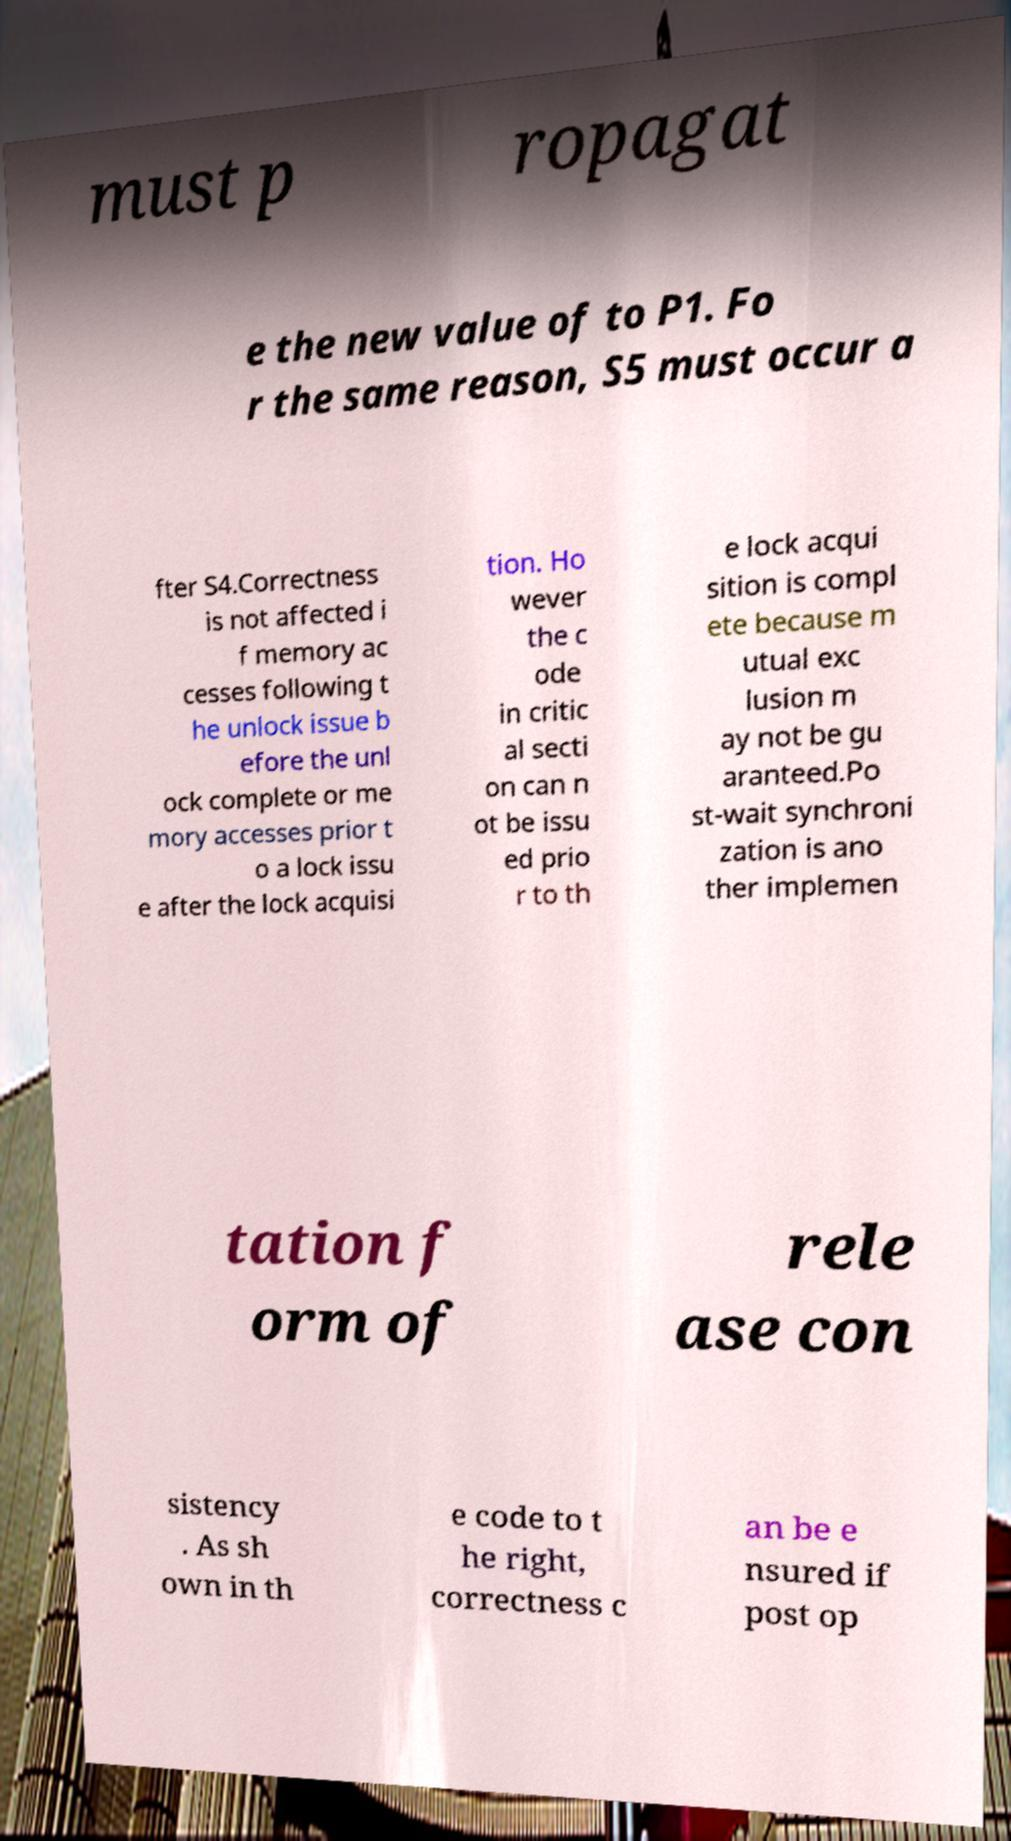What messages or text are displayed in this image? I need them in a readable, typed format. must p ropagat e the new value of to P1. Fo r the same reason, S5 must occur a fter S4.Correctness is not affected i f memory ac cesses following t he unlock issue b efore the unl ock complete or me mory accesses prior t o a lock issu e after the lock acquisi tion. Ho wever the c ode in critic al secti on can n ot be issu ed prio r to th e lock acqui sition is compl ete because m utual exc lusion m ay not be gu aranteed.Po st-wait synchroni zation is ano ther implemen tation f orm of rele ase con sistency . As sh own in th e code to t he right, correctness c an be e nsured if post op 